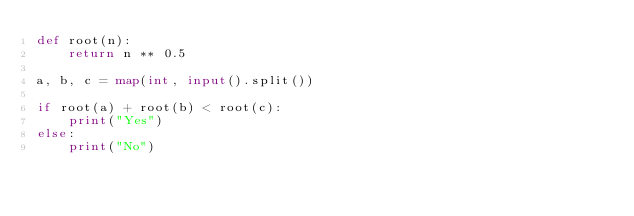<code> <loc_0><loc_0><loc_500><loc_500><_Python_>def root(n):
    return n ** 0.5

a, b, c = map(int, input().split())

if root(a) + root(b) < root(c):
    print("Yes")
else:
    print("No")</code> 